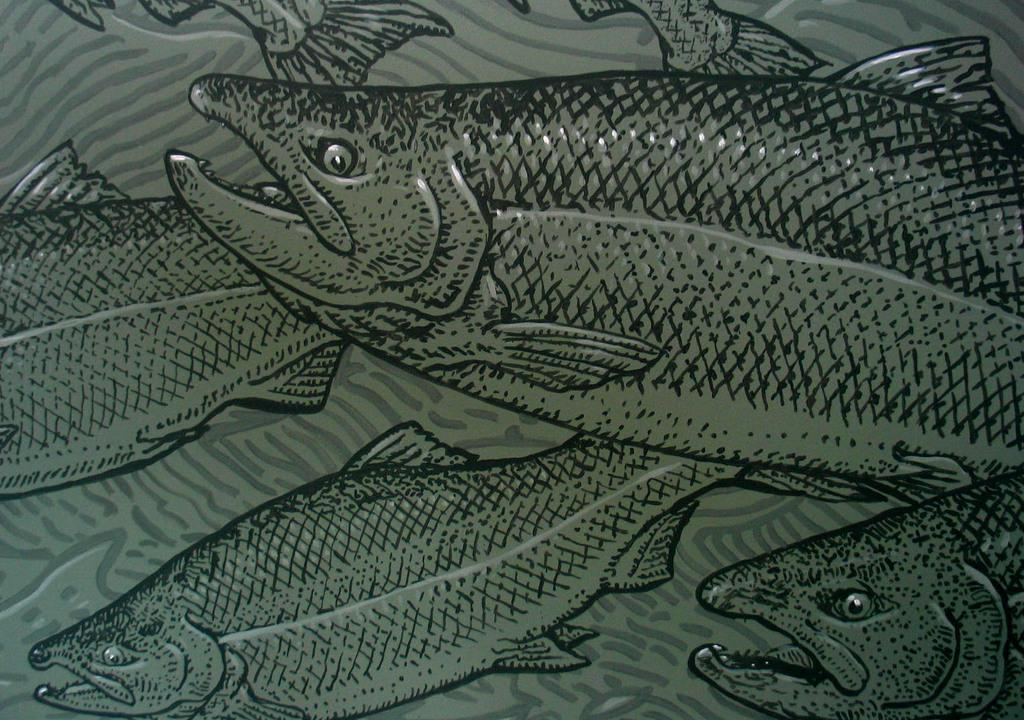What is the main subject of the art piece in the image? The main subject of the art piece in the image is fishes. What is the background color of the art piece? The art piece is on a green color board. What type of prose is being recited by the servant in the image? There is no servant or prose present in the image; it features an art piece with fishes on a green color board. 